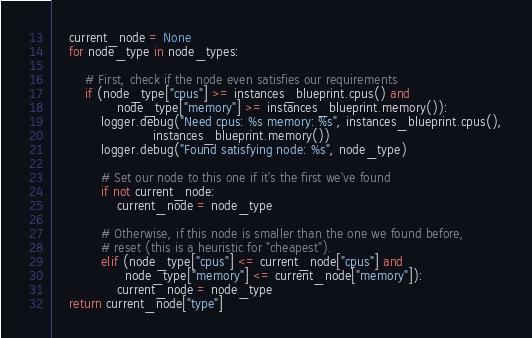<code> <loc_0><loc_0><loc_500><loc_500><_Python_>    current_node = None
    for node_type in node_types:

        # First, check if the node even satisfies our requirements
        if (node_type["cpus"] >= instances_blueprint.cpus() and
                node_type["memory"] >= instances_blueprint.memory()):
            logger.debug("Need cpus: %s memory: %s", instances_blueprint.cpus(),
                         instances_blueprint.memory())
            logger.debug("Found satisfying node: %s", node_type)

            # Set our node to this one if it's the first we've found
            if not current_node:
                current_node = node_type

            # Otherwise, if this node is smaller than the one we found before,
            # reset (this is a heuristic for "cheapest").
            elif (node_type["cpus"] <= current_node["cpus"] and
                  node_type["memory"] <= current_node["memory"]):
                current_node = node_type
    return current_node["type"]
</code> 